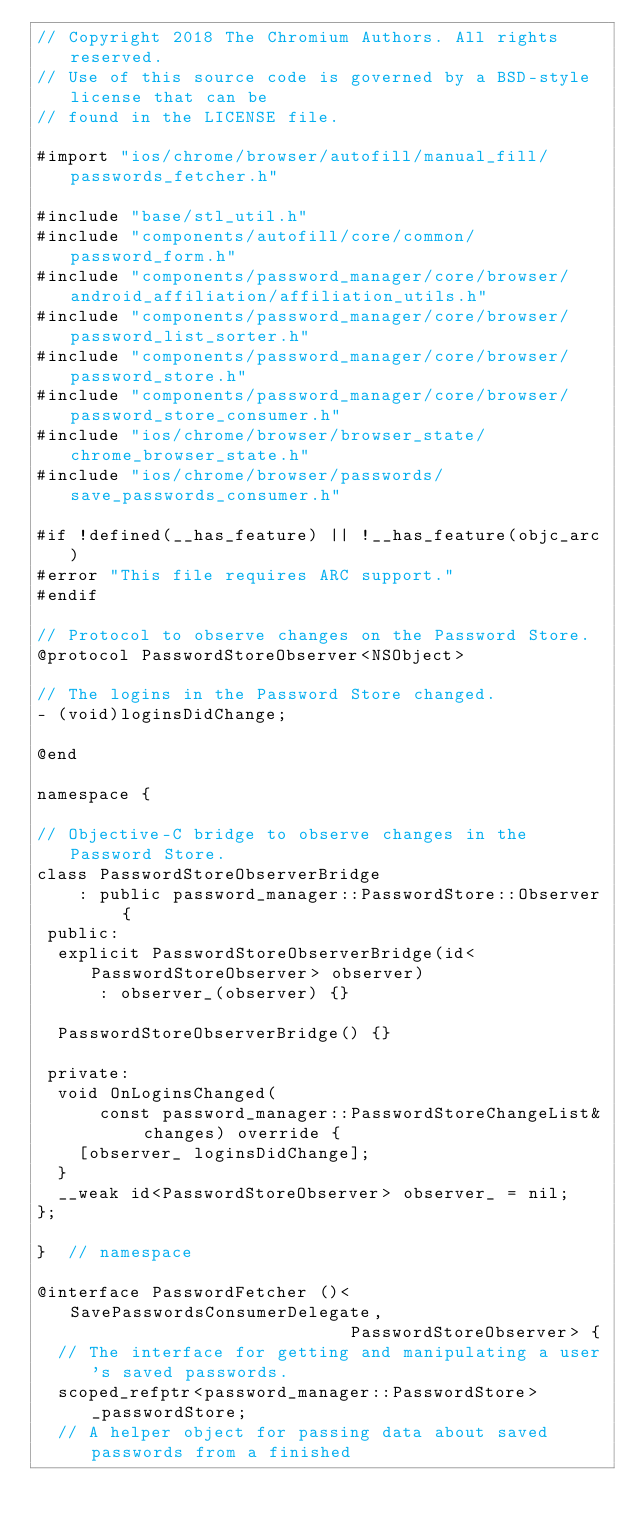Convert code to text. <code><loc_0><loc_0><loc_500><loc_500><_ObjectiveC_>// Copyright 2018 The Chromium Authors. All rights reserved.
// Use of this source code is governed by a BSD-style license that can be
// found in the LICENSE file.

#import "ios/chrome/browser/autofill/manual_fill/passwords_fetcher.h"

#include "base/stl_util.h"
#include "components/autofill/core/common/password_form.h"
#include "components/password_manager/core/browser/android_affiliation/affiliation_utils.h"
#include "components/password_manager/core/browser/password_list_sorter.h"
#include "components/password_manager/core/browser/password_store.h"
#include "components/password_manager/core/browser/password_store_consumer.h"
#include "ios/chrome/browser/browser_state/chrome_browser_state.h"
#include "ios/chrome/browser/passwords/save_passwords_consumer.h"

#if !defined(__has_feature) || !__has_feature(objc_arc)
#error "This file requires ARC support."
#endif

// Protocol to observe changes on the Password Store.
@protocol PasswordStoreObserver<NSObject>

// The logins in the Password Store changed.
- (void)loginsDidChange;

@end

namespace {

// Objective-C bridge to observe changes in the Password Store.
class PasswordStoreObserverBridge
    : public password_manager::PasswordStore::Observer {
 public:
  explicit PasswordStoreObserverBridge(id<PasswordStoreObserver> observer)
      : observer_(observer) {}

  PasswordStoreObserverBridge() {}

 private:
  void OnLoginsChanged(
      const password_manager::PasswordStoreChangeList& changes) override {
    [observer_ loginsDidChange];
  }
  __weak id<PasswordStoreObserver> observer_ = nil;
};

}  // namespace

@interface PasswordFetcher ()<SavePasswordsConsumerDelegate,
                              PasswordStoreObserver> {
  // The interface for getting and manipulating a user's saved passwords.
  scoped_refptr<password_manager::PasswordStore> _passwordStore;
  // A helper object for passing data about saved passwords from a finished</code> 